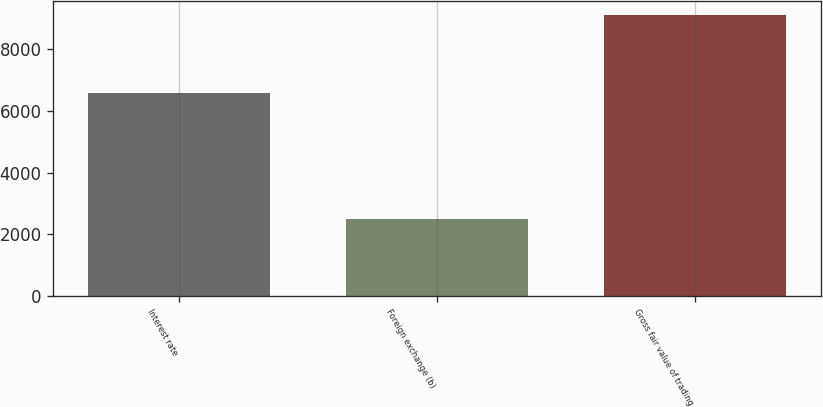Convert chart. <chart><loc_0><loc_0><loc_500><loc_500><bar_chart><fcel>Interest rate<fcel>Foreign exchange (b)<fcel>Gross fair value of trading<nl><fcel>6568<fcel>2497<fcel>9104<nl></chart> 